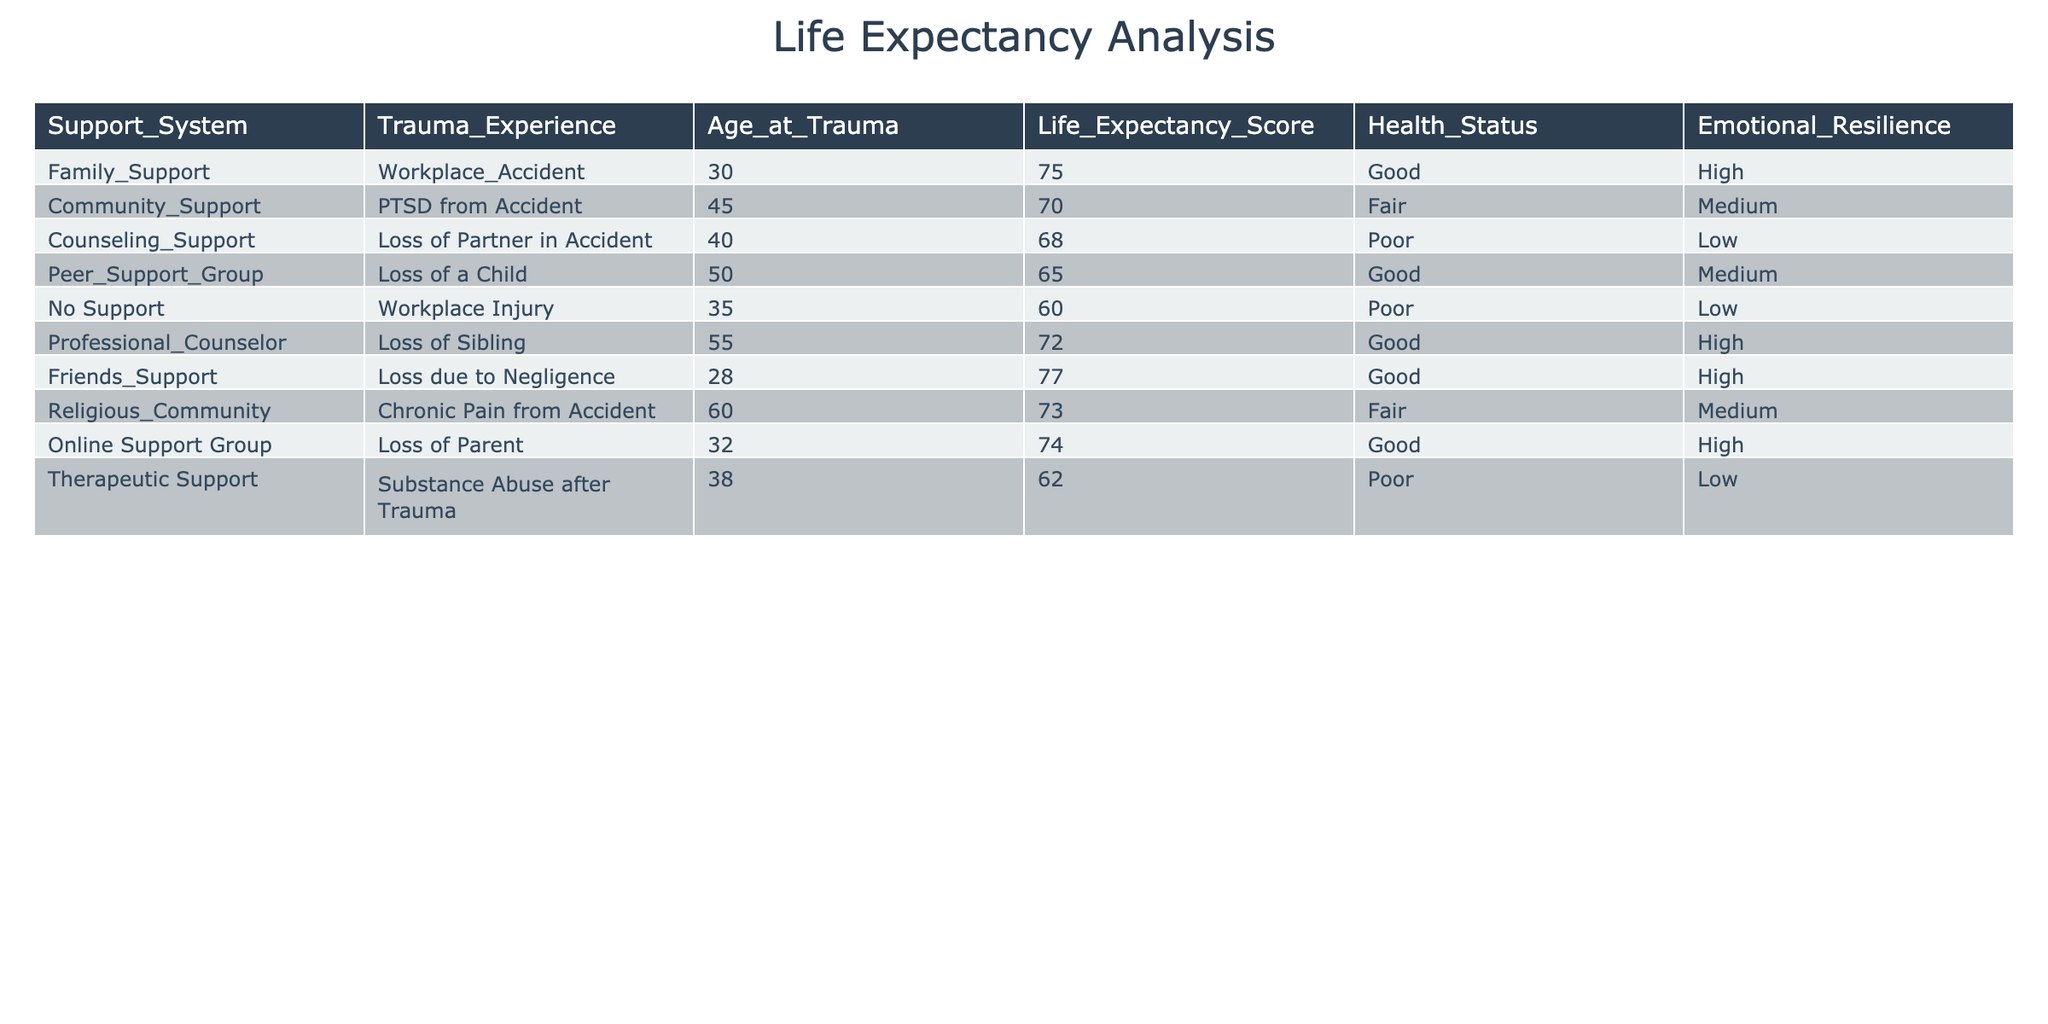What is the life expectancy score for individuals with family support? The table shows that for individuals with family support, the life expectancy score is 75.
Answer: 75 What trauma experience has the lowest life expectancy score? By reviewing the table, the trauma experience "Loss of a Child" has the lowest life expectancy score of 65.
Answer: 65 Is there a correlation between support system type and health status? A review of the table indicates that those with "No Support" and "Therapeutic Support" have poor health status, while those with family and professional counseling support report good health status. Therefore, it can be inferred that a supportive system generally relates to better health status.
Answer: Yes What is the average life expectancy score for those who experienced loss due to accidents? The individuals with loss due to accidents are identified as those with "Counseling Support," "Peer Support Group," "No Support," and "Online Support Group." Their life expectancy scores are 68, 65, 60, and 74. Summing these scores gives 267, and dividing by 4 gives an average of 66.75.
Answer: 66.75 Are individuals with emotional resilience rated as high experiencing better life expectancy scores compared to those with low resilience? The table shows individuals with high emotional resilience ("Family Support," "Professional Counselor," "Friends Support," "Online Support Group") have life expectancy scores of 75, 72, 77, and 74, which average to approximately 74.5. In contrast, those with low resilience ("Counseling Support," "No Support," "Therapeutic Support") have scores of 68, 60, and 62, averaging approximately 63.33. Therefore, it is clear that high resilience correlates with better life expectancy.
Answer: Yes What is the difference in life expectancy scores between those with community support and those without any support? The life expectancy score for individuals with community support is 70 and for those without any support is 60. The difference is calculated by subtracting the lower score from the higher score: 70 - 60 = 10.
Answer: 10 